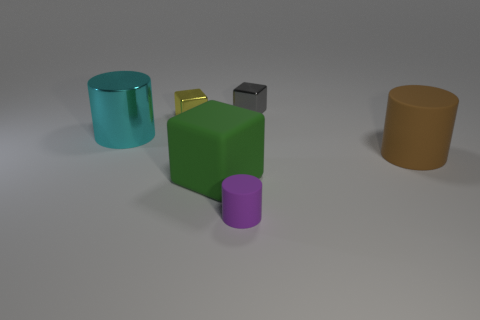How many matte things are either big things or green cubes?
Your answer should be compact. 2. Is there anything else that has the same material as the yellow cube?
Make the answer very short. Yes. There is a rubber object that is on the left side of the purple cylinder; are there any tiny yellow metallic blocks that are in front of it?
Make the answer very short. No. How many things are either blocks that are behind the green object or small objects to the left of the gray object?
Make the answer very short. 3. Is there anything else of the same color as the large rubber block?
Offer a very short reply. No. There is a block that is to the left of the big rubber thing that is to the left of the large object right of the rubber cube; what color is it?
Offer a terse response. Yellow. There is a rubber cylinder to the right of the tiny thing that is in front of the large green block; what is its size?
Keep it short and to the point. Large. There is a thing that is behind the purple cylinder and in front of the big brown rubber object; what is its material?
Your response must be concise. Rubber. There is a green rubber object; is its size the same as the rubber cylinder that is in front of the brown cylinder?
Make the answer very short. No. Are there any cyan matte cubes?
Offer a terse response. No. 